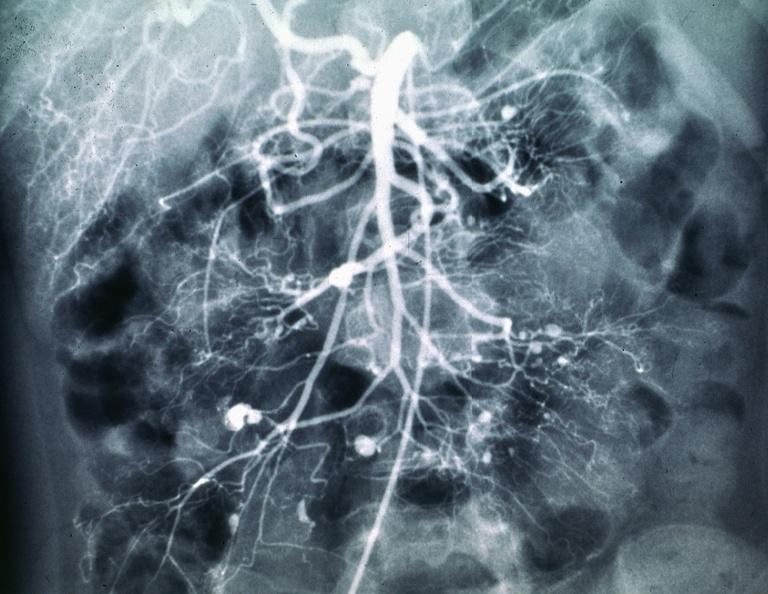does omphalocele show polyarteritis nodosa mesentaric artery arteriogram?
Answer the question using a single word or phrase. No 